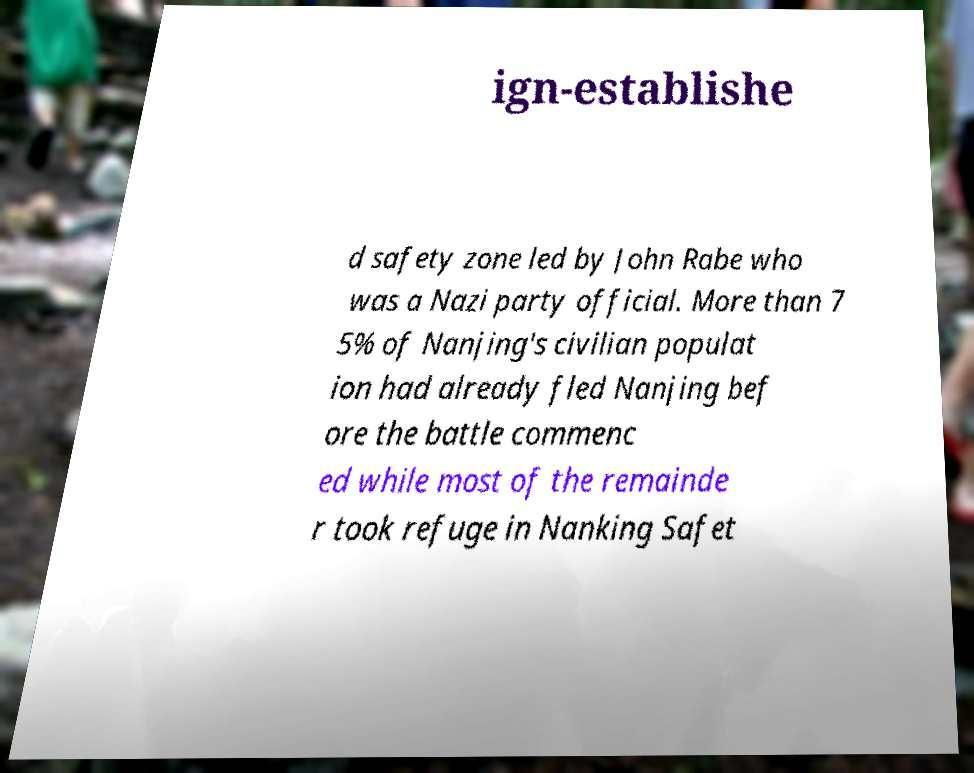Could you assist in decoding the text presented in this image and type it out clearly? ign-establishe d safety zone led by John Rabe who was a Nazi party official. More than 7 5% of Nanjing's civilian populat ion had already fled Nanjing bef ore the battle commenc ed while most of the remainde r took refuge in Nanking Safet 